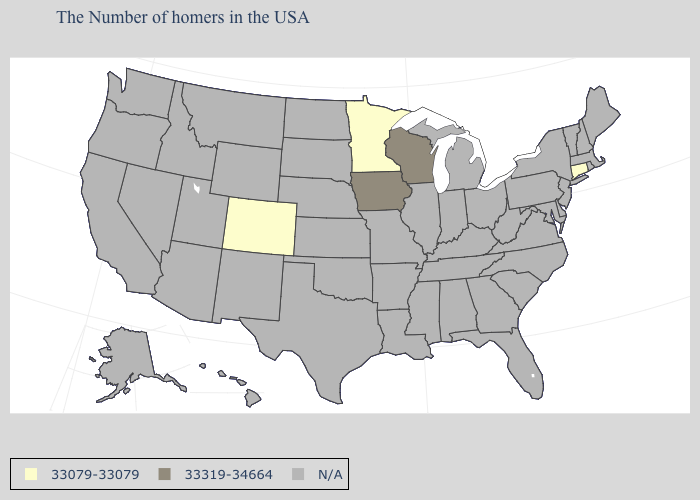Does Minnesota have the lowest value in the USA?
Concise answer only. Yes. What is the value of Wyoming?
Keep it brief. N/A. What is the highest value in the USA?
Concise answer only. 33319-34664. Name the states that have a value in the range 33319-34664?
Write a very short answer. Wisconsin, Iowa. Which states have the highest value in the USA?
Concise answer only. Wisconsin, Iowa. What is the value of Alaska?
Keep it brief. N/A. What is the value of West Virginia?
Keep it brief. N/A. What is the value of Nebraska?
Write a very short answer. N/A. What is the highest value in the MidWest ?
Be succinct. 33319-34664. What is the value of Florida?
Give a very brief answer. N/A. Name the states that have a value in the range 33079-33079?
Concise answer only. Connecticut, Minnesota, Colorado. Name the states that have a value in the range 33079-33079?
Be succinct. Connecticut, Minnesota, Colorado. What is the value of New York?
Write a very short answer. N/A. Among the states that border New Mexico , which have the lowest value?
Answer briefly. Colorado. 